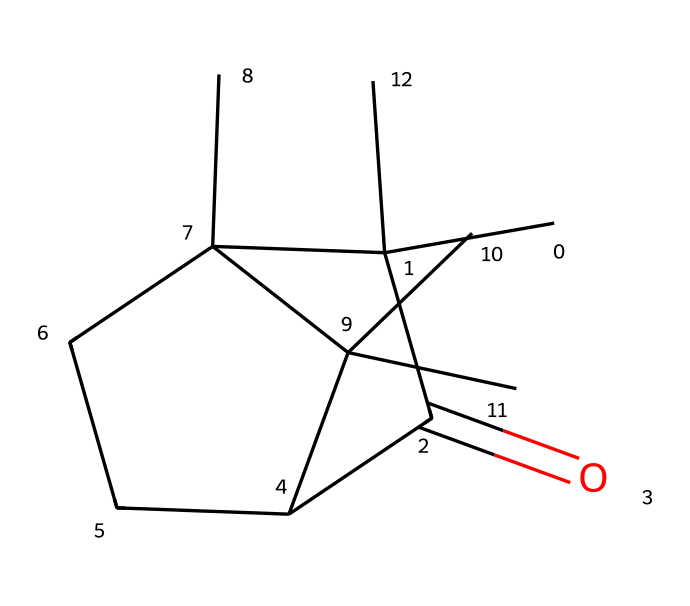What is the IUPAC name of this compound? To identify the IUPAC name of the compound from the SMILES representation, we analyze the structure depicted by the SMILES. The central feature is a carbonyl group (C=O) indicating it is a ketone. Based on the arrangement of carbon atoms and substituents, the full name is deduced using IUPAC nomenclature rules for branched ketones.
Answer: camphor How many carbon atoms are present in the molecule? We can count the carbon atoms in the SMILES representation. The notation "C" represents carbon atoms, and branches or rings seen in the SMILES provide additional structural information that indicates the presence of multiple carbon atoms. Upon counting all the distinct "C" parts, we find a total of 10 carbon atoms.
Answer: 10 What functional group is present in camphor? By examining the SMILES, we identify the key feature of the molecule—the carbonyl group (C=O)—which signifies that this compound belongs to the class of ketones. Thus, the functional group present here is specifically the carbonyl functional group.
Answer: carbonyl What type of compound is camphor classified as? From the SMILES structure, we notice the presence of a carbonyl group (C=O) that is characteristic of ketones. Additionally, the arrangement of the carbon atoms confirms that it is not an aldehyde or other functional groups. Hence, it is classified as a ketone.
Answer: ketone How many cyclic structures are present in the molecule? In interpreting the SMILES notation, we observe that there is a ring structure, indicated by the numbers “1” and “2” in the SMILES, which denote the start and end of rings. Upon examining the rings, we find two distinct cyclic structures in the compound.
Answer: 2 What is the degree of saturation for camphor? To calculate the degree of saturation, we count the number of ring closures and double bonds based on the structure represented in the SMILES. For camphor, we find that the structure contains one carbonyl (C=O) and two rings, leading us to conclude it has a degree of saturation of 5.
Answer: 5 